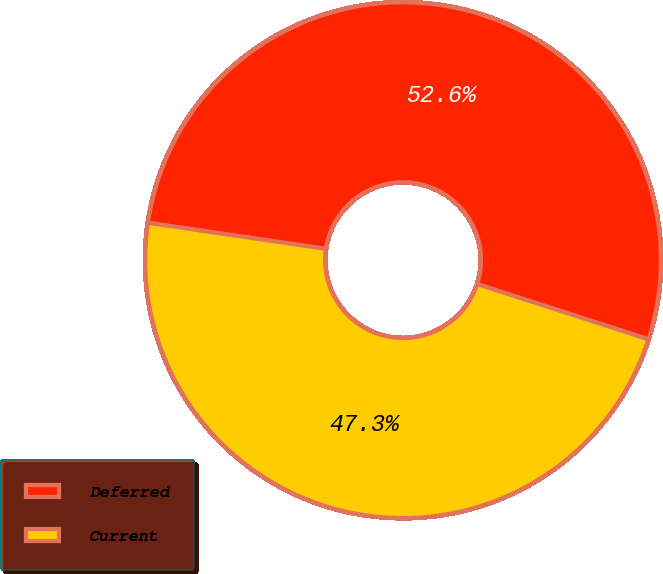<chart> <loc_0><loc_0><loc_500><loc_500><pie_chart><fcel>Deferred<fcel>Current<nl><fcel>52.65%<fcel>47.35%<nl></chart> 